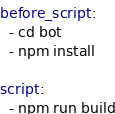Convert code to text. <code><loc_0><loc_0><loc_500><loc_500><_YAML_>before_script:
  - cd bot
  - npm install

script:
  - npm run build
</code> 